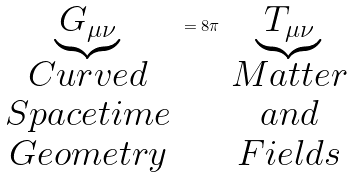Convert formula to latex. <formula><loc_0><loc_0><loc_500><loc_500>\underbrace { G _ { \mu \nu } } _ { \begin{array} { c } C u r v e d \\ S p a c e t i m e \\ G e o m e t r y \end{array} } = 8 \pi \underbrace { T _ { \mu \nu } } _ { \begin{array} { c } M a t t e r \\ a n d \\ F i e l d s \end{array} }</formula> 